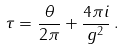Convert formula to latex. <formula><loc_0><loc_0><loc_500><loc_500>\tau = \frac { \theta } { 2 \pi } + \frac { 4 \pi i } { g ^ { 2 } } \, .</formula> 